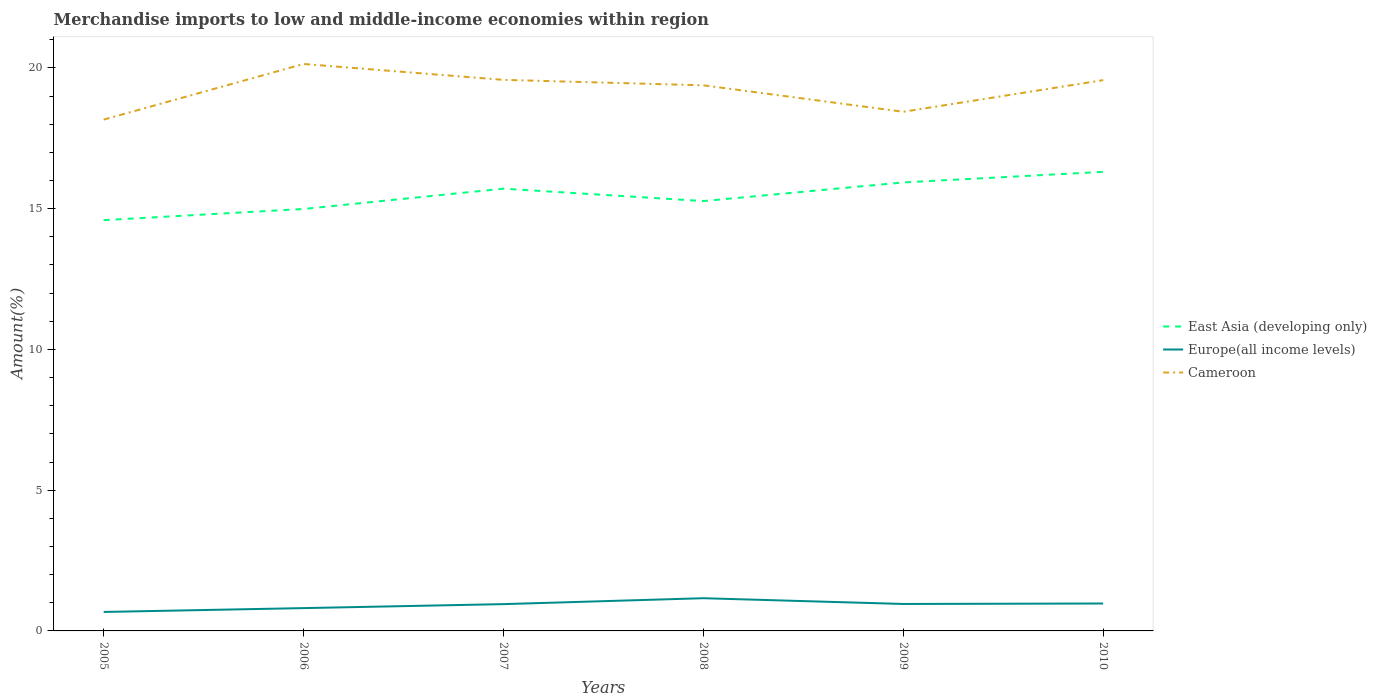Across all years, what is the maximum percentage of amount earned from merchandise imports in East Asia (developing only)?
Make the answer very short. 14.59. In which year was the percentage of amount earned from merchandise imports in East Asia (developing only) maximum?
Offer a very short reply. 2005. What is the total percentage of amount earned from merchandise imports in East Asia (developing only) in the graph?
Your answer should be very brief. -0.28. What is the difference between the highest and the second highest percentage of amount earned from merchandise imports in Europe(all income levels)?
Provide a short and direct response. 0.49. What is the difference between the highest and the lowest percentage of amount earned from merchandise imports in East Asia (developing only)?
Your response must be concise. 3. How many lines are there?
Your answer should be compact. 3. Are the values on the major ticks of Y-axis written in scientific E-notation?
Your response must be concise. No. Does the graph contain grids?
Provide a succinct answer. No. Where does the legend appear in the graph?
Your answer should be compact. Center right. How are the legend labels stacked?
Your answer should be very brief. Vertical. What is the title of the graph?
Your answer should be compact. Merchandise imports to low and middle-income economies within region. What is the label or title of the X-axis?
Ensure brevity in your answer.  Years. What is the label or title of the Y-axis?
Your response must be concise. Amount(%). What is the Amount(%) in East Asia (developing only) in 2005?
Your response must be concise. 14.59. What is the Amount(%) of Europe(all income levels) in 2005?
Give a very brief answer. 0.67. What is the Amount(%) of Cameroon in 2005?
Your answer should be very brief. 18.17. What is the Amount(%) in East Asia (developing only) in 2006?
Your answer should be compact. 14.99. What is the Amount(%) of Europe(all income levels) in 2006?
Provide a short and direct response. 0.81. What is the Amount(%) in Cameroon in 2006?
Ensure brevity in your answer.  20.14. What is the Amount(%) of East Asia (developing only) in 2007?
Provide a short and direct response. 15.71. What is the Amount(%) in Europe(all income levels) in 2007?
Keep it short and to the point. 0.95. What is the Amount(%) in Cameroon in 2007?
Your response must be concise. 19.58. What is the Amount(%) in East Asia (developing only) in 2008?
Give a very brief answer. 15.27. What is the Amount(%) of Europe(all income levels) in 2008?
Keep it short and to the point. 1.16. What is the Amount(%) in Cameroon in 2008?
Your answer should be compact. 19.38. What is the Amount(%) in East Asia (developing only) in 2009?
Give a very brief answer. 15.93. What is the Amount(%) of Europe(all income levels) in 2009?
Your answer should be compact. 0.96. What is the Amount(%) in Cameroon in 2009?
Offer a very short reply. 18.44. What is the Amount(%) of East Asia (developing only) in 2010?
Give a very brief answer. 16.31. What is the Amount(%) in Europe(all income levels) in 2010?
Ensure brevity in your answer.  0.97. What is the Amount(%) of Cameroon in 2010?
Give a very brief answer. 19.57. Across all years, what is the maximum Amount(%) in East Asia (developing only)?
Keep it short and to the point. 16.31. Across all years, what is the maximum Amount(%) of Europe(all income levels)?
Provide a succinct answer. 1.16. Across all years, what is the maximum Amount(%) in Cameroon?
Keep it short and to the point. 20.14. Across all years, what is the minimum Amount(%) of East Asia (developing only)?
Provide a short and direct response. 14.59. Across all years, what is the minimum Amount(%) of Europe(all income levels)?
Offer a terse response. 0.67. Across all years, what is the minimum Amount(%) in Cameroon?
Give a very brief answer. 18.17. What is the total Amount(%) of East Asia (developing only) in the graph?
Offer a very short reply. 92.81. What is the total Amount(%) of Europe(all income levels) in the graph?
Your response must be concise. 5.53. What is the total Amount(%) in Cameroon in the graph?
Provide a succinct answer. 115.28. What is the difference between the Amount(%) in East Asia (developing only) in 2005 and that in 2006?
Make the answer very short. -0.4. What is the difference between the Amount(%) in Europe(all income levels) in 2005 and that in 2006?
Your response must be concise. -0.14. What is the difference between the Amount(%) of Cameroon in 2005 and that in 2006?
Your answer should be compact. -1.98. What is the difference between the Amount(%) in East Asia (developing only) in 2005 and that in 2007?
Make the answer very short. -1.12. What is the difference between the Amount(%) in Europe(all income levels) in 2005 and that in 2007?
Provide a succinct answer. -0.28. What is the difference between the Amount(%) of Cameroon in 2005 and that in 2007?
Provide a succinct answer. -1.41. What is the difference between the Amount(%) of East Asia (developing only) in 2005 and that in 2008?
Ensure brevity in your answer.  -0.68. What is the difference between the Amount(%) in Europe(all income levels) in 2005 and that in 2008?
Make the answer very short. -0.49. What is the difference between the Amount(%) in Cameroon in 2005 and that in 2008?
Offer a terse response. -1.22. What is the difference between the Amount(%) of East Asia (developing only) in 2005 and that in 2009?
Give a very brief answer. -1.34. What is the difference between the Amount(%) in Europe(all income levels) in 2005 and that in 2009?
Give a very brief answer. -0.28. What is the difference between the Amount(%) in Cameroon in 2005 and that in 2009?
Your answer should be compact. -0.28. What is the difference between the Amount(%) in East Asia (developing only) in 2005 and that in 2010?
Give a very brief answer. -1.72. What is the difference between the Amount(%) of Europe(all income levels) in 2005 and that in 2010?
Your answer should be very brief. -0.3. What is the difference between the Amount(%) of Cameroon in 2005 and that in 2010?
Offer a terse response. -1.4. What is the difference between the Amount(%) of East Asia (developing only) in 2006 and that in 2007?
Your answer should be very brief. -0.72. What is the difference between the Amount(%) of Europe(all income levels) in 2006 and that in 2007?
Give a very brief answer. -0.14. What is the difference between the Amount(%) in Cameroon in 2006 and that in 2007?
Ensure brevity in your answer.  0.56. What is the difference between the Amount(%) of East Asia (developing only) in 2006 and that in 2008?
Provide a succinct answer. -0.28. What is the difference between the Amount(%) of Europe(all income levels) in 2006 and that in 2008?
Provide a succinct answer. -0.35. What is the difference between the Amount(%) in Cameroon in 2006 and that in 2008?
Your response must be concise. 0.76. What is the difference between the Amount(%) in East Asia (developing only) in 2006 and that in 2009?
Your answer should be compact. -0.94. What is the difference between the Amount(%) of Europe(all income levels) in 2006 and that in 2009?
Keep it short and to the point. -0.15. What is the difference between the Amount(%) in Cameroon in 2006 and that in 2009?
Your response must be concise. 1.7. What is the difference between the Amount(%) of East Asia (developing only) in 2006 and that in 2010?
Give a very brief answer. -1.32. What is the difference between the Amount(%) in Europe(all income levels) in 2006 and that in 2010?
Your response must be concise. -0.16. What is the difference between the Amount(%) of Cameroon in 2006 and that in 2010?
Make the answer very short. 0.57. What is the difference between the Amount(%) in East Asia (developing only) in 2007 and that in 2008?
Your response must be concise. 0.44. What is the difference between the Amount(%) in Europe(all income levels) in 2007 and that in 2008?
Keep it short and to the point. -0.21. What is the difference between the Amount(%) in Cameroon in 2007 and that in 2008?
Give a very brief answer. 0.19. What is the difference between the Amount(%) of East Asia (developing only) in 2007 and that in 2009?
Keep it short and to the point. -0.22. What is the difference between the Amount(%) in Europe(all income levels) in 2007 and that in 2009?
Ensure brevity in your answer.  -0.01. What is the difference between the Amount(%) of Cameroon in 2007 and that in 2009?
Give a very brief answer. 1.13. What is the difference between the Amount(%) of East Asia (developing only) in 2007 and that in 2010?
Offer a terse response. -0.6. What is the difference between the Amount(%) of Europe(all income levels) in 2007 and that in 2010?
Provide a short and direct response. -0.02. What is the difference between the Amount(%) of East Asia (developing only) in 2008 and that in 2009?
Your answer should be very brief. -0.66. What is the difference between the Amount(%) of Europe(all income levels) in 2008 and that in 2009?
Your response must be concise. 0.2. What is the difference between the Amount(%) of Cameroon in 2008 and that in 2009?
Offer a terse response. 0.94. What is the difference between the Amount(%) of East Asia (developing only) in 2008 and that in 2010?
Keep it short and to the point. -1.04. What is the difference between the Amount(%) in Europe(all income levels) in 2008 and that in 2010?
Offer a terse response. 0.19. What is the difference between the Amount(%) of Cameroon in 2008 and that in 2010?
Your response must be concise. -0.18. What is the difference between the Amount(%) in East Asia (developing only) in 2009 and that in 2010?
Your answer should be compact. -0.38. What is the difference between the Amount(%) of Europe(all income levels) in 2009 and that in 2010?
Keep it short and to the point. -0.02. What is the difference between the Amount(%) of Cameroon in 2009 and that in 2010?
Ensure brevity in your answer.  -1.12. What is the difference between the Amount(%) in East Asia (developing only) in 2005 and the Amount(%) in Europe(all income levels) in 2006?
Your response must be concise. 13.78. What is the difference between the Amount(%) of East Asia (developing only) in 2005 and the Amount(%) of Cameroon in 2006?
Offer a terse response. -5.55. What is the difference between the Amount(%) in Europe(all income levels) in 2005 and the Amount(%) in Cameroon in 2006?
Provide a succinct answer. -19.47. What is the difference between the Amount(%) of East Asia (developing only) in 2005 and the Amount(%) of Europe(all income levels) in 2007?
Provide a succinct answer. 13.64. What is the difference between the Amount(%) in East Asia (developing only) in 2005 and the Amount(%) in Cameroon in 2007?
Offer a very short reply. -4.98. What is the difference between the Amount(%) of Europe(all income levels) in 2005 and the Amount(%) of Cameroon in 2007?
Your answer should be very brief. -18.9. What is the difference between the Amount(%) of East Asia (developing only) in 2005 and the Amount(%) of Europe(all income levels) in 2008?
Offer a terse response. 13.43. What is the difference between the Amount(%) of East Asia (developing only) in 2005 and the Amount(%) of Cameroon in 2008?
Offer a terse response. -4.79. What is the difference between the Amount(%) in Europe(all income levels) in 2005 and the Amount(%) in Cameroon in 2008?
Ensure brevity in your answer.  -18.71. What is the difference between the Amount(%) in East Asia (developing only) in 2005 and the Amount(%) in Europe(all income levels) in 2009?
Keep it short and to the point. 13.64. What is the difference between the Amount(%) in East Asia (developing only) in 2005 and the Amount(%) in Cameroon in 2009?
Keep it short and to the point. -3.85. What is the difference between the Amount(%) in Europe(all income levels) in 2005 and the Amount(%) in Cameroon in 2009?
Your response must be concise. -17.77. What is the difference between the Amount(%) in East Asia (developing only) in 2005 and the Amount(%) in Europe(all income levels) in 2010?
Provide a succinct answer. 13.62. What is the difference between the Amount(%) of East Asia (developing only) in 2005 and the Amount(%) of Cameroon in 2010?
Offer a very short reply. -4.97. What is the difference between the Amount(%) of Europe(all income levels) in 2005 and the Amount(%) of Cameroon in 2010?
Provide a succinct answer. -18.89. What is the difference between the Amount(%) in East Asia (developing only) in 2006 and the Amount(%) in Europe(all income levels) in 2007?
Ensure brevity in your answer.  14.04. What is the difference between the Amount(%) in East Asia (developing only) in 2006 and the Amount(%) in Cameroon in 2007?
Provide a succinct answer. -4.59. What is the difference between the Amount(%) in Europe(all income levels) in 2006 and the Amount(%) in Cameroon in 2007?
Offer a very short reply. -18.77. What is the difference between the Amount(%) of East Asia (developing only) in 2006 and the Amount(%) of Europe(all income levels) in 2008?
Keep it short and to the point. 13.83. What is the difference between the Amount(%) in East Asia (developing only) in 2006 and the Amount(%) in Cameroon in 2008?
Your answer should be compact. -4.39. What is the difference between the Amount(%) of Europe(all income levels) in 2006 and the Amount(%) of Cameroon in 2008?
Provide a succinct answer. -18.57. What is the difference between the Amount(%) in East Asia (developing only) in 2006 and the Amount(%) in Europe(all income levels) in 2009?
Your answer should be very brief. 14.03. What is the difference between the Amount(%) in East Asia (developing only) in 2006 and the Amount(%) in Cameroon in 2009?
Offer a terse response. -3.45. What is the difference between the Amount(%) in Europe(all income levels) in 2006 and the Amount(%) in Cameroon in 2009?
Provide a succinct answer. -17.63. What is the difference between the Amount(%) in East Asia (developing only) in 2006 and the Amount(%) in Europe(all income levels) in 2010?
Provide a succinct answer. 14.02. What is the difference between the Amount(%) in East Asia (developing only) in 2006 and the Amount(%) in Cameroon in 2010?
Keep it short and to the point. -4.58. What is the difference between the Amount(%) in Europe(all income levels) in 2006 and the Amount(%) in Cameroon in 2010?
Keep it short and to the point. -18.76. What is the difference between the Amount(%) in East Asia (developing only) in 2007 and the Amount(%) in Europe(all income levels) in 2008?
Provide a succinct answer. 14.55. What is the difference between the Amount(%) in East Asia (developing only) in 2007 and the Amount(%) in Cameroon in 2008?
Give a very brief answer. -3.67. What is the difference between the Amount(%) of Europe(all income levels) in 2007 and the Amount(%) of Cameroon in 2008?
Offer a terse response. -18.43. What is the difference between the Amount(%) in East Asia (developing only) in 2007 and the Amount(%) in Europe(all income levels) in 2009?
Your response must be concise. 14.75. What is the difference between the Amount(%) of East Asia (developing only) in 2007 and the Amount(%) of Cameroon in 2009?
Keep it short and to the point. -2.73. What is the difference between the Amount(%) of Europe(all income levels) in 2007 and the Amount(%) of Cameroon in 2009?
Keep it short and to the point. -17.49. What is the difference between the Amount(%) of East Asia (developing only) in 2007 and the Amount(%) of Europe(all income levels) in 2010?
Offer a very short reply. 14.74. What is the difference between the Amount(%) of East Asia (developing only) in 2007 and the Amount(%) of Cameroon in 2010?
Your answer should be very brief. -3.86. What is the difference between the Amount(%) in Europe(all income levels) in 2007 and the Amount(%) in Cameroon in 2010?
Make the answer very short. -18.61. What is the difference between the Amount(%) in East Asia (developing only) in 2008 and the Amount(%) in Europe(all income levels) in 2009?
Give a very brief answer. 14.31. What is the difference between the Amount(%) in East Asia (developing only) in 2008 and the Amount(%) in Cameroon in 2009?
Give a very brief answer. -3.17. What is the difference between the Amount(%) in Europe(all income levels) in 2008 and the Amount(%) in Cameroon in 2009?
Make the answer very short. -17.28. What is the difference between the Amount(%) in East Asia (developing only) in 2008 and the Amount(%) in Europe(all income levels) in 2010?
Ensure brevity in your answer.  14.3. What is the difference between the Amount(%) in East Asia (developing only) in 2008 and the Amount(%) in Cameroon in 2010?
Ensure brevity in your answer.  -4.3. What is the difference between the Amount(%) of Europe(all income levels) in 2008 and the Amount(%) of Cameroon in 2010?
Your response must be concise. -18.4. What is the difference between the Amount(%) in East Asia (developing only) in 2009 and the Amount(%) in Europe(all income levels) in 2010?
Give a very brief answer. 14.96. What is the difference between the Amount(%) in East Asia (developing only) in 2009 and the Amount(%) in Cameroon in 2010?
Provide a short and direct response. -3.63. What is the difference between the Amount(%) in Europe(all income levels) in 2009 and the Amount(%) in Cameroon in 2010?
Make the answer very short. -18.61. What is the average Amount(%) in East Asia (developing only) per year?
Your response must be concise. 15.47. What is the average Amount(%) of Europe(all income levels) per year?
Provide a short and direct response. 0.92. What is the average Amount(%) of Cameroon per year?
Your answer should be compact. 19.21. In the year 2005, what is the difference between the Amount(%) in East Asia (developing only) and Amount(%) in Europe(all income levels)?
Give a very brief answer. 13.92. In the year 2005, what is the difference between the Amount(%) of East Asia (developing only) and Amount(%) of Cameroon?
Offer a terse response. -3.57. In the year 2005, what is the difference between the Amount(%) of Europe(all income levels) and Amount(%) of Cameroon?
Your answer should be compact. -17.49. In the year 2006, what is the difference between the Amount(%) of East Asia (developing only) and Amount(%) of Europe(all income levels)?
Provide a succinct answer. 14.18. In the year 2006, what is the difference between the Amount(%) of East Asia (developing only) and Amount(%) of Cameroon?
Your answer should be very brief. -5.15. In the year 2006, what is the difference between the Amount(%) in Europe(all income levels) and Amount(%) in Cameroon?
Keep it short and to the point. -19.33. In the year 2007, what is the difference between the Amount(%) of East Asia (developing only) and Amount(%) of Europe(all income levels)?
Offer a terse response. 14.76. In the year 2007, what is the difference between the Amount(%) of East Asia (developing only) and Amount(%) of Cameroon?
Offer a very short reply. -3.87. In the year 2007, what is the difference between the Amount(%) in Europe(all income levels) and Amount(%) in Cameroon?
Provide a succinct answer. -18.62. In the year 2008, what is the difference between the Amount(%) in East Asia (developing only) and Amount(%) in Europe(all income levels)?
Offer a terse response. 14.11. In the year 2008, what is the difference between the Amount(%) of East Asia (developing only) and Amount(%) of Cameroon?
Your answer should be compact. -4.11. In the year 2008, what is the difference between the Amount(%) of Europe(all income levels) and Amount(%) of Cameroon?
Offer a very short reply. -18.22. In the year 2009, what is the difference between the Amount(%) of East Asia (developing only) and Amount(%) of Europe(all income levels)?
Offer a terse response. 14.98. In the year 2009, what is the difference between the Amount(%) of East Asia (developing only) and Amount(%) of Cameroon?
Offer a very short reply. -2.51. In the year 2009, what is the difference between the Amount(%) in Europe(all income levels) and Amount(%) in Cameroon?
Provide a short and direct response. -17.49. In the year 2010, what is the difference between the Amount(%) in East Asia (developing only) and Amount(%) in Europe(all income levels)?
Offer a terse response. 15.33. In the year 2010, what is the difference between the Amount(%) in East Asia (developing only) and Amount(%) in Cameroon?
Your answer should be compact. -3.26. In the year 2010, what is the difference between the Amount(%) of Europe(all income levels) and Amount(%) of Cameroon?
Your response must be concise. -18.59. What is the ratio of the Amount(%) in East Asia (developing only) in 2005 to that in 2006?
Give a very brief answer. 0.97. What is the ratio of the Amount(%) of Europe(all income levels) in 2005 to that in 2006?
Your answer should be very brief. 0.83. What is the ratio of the Amount(%) in Cameroon in 2005 to that in 2006?
Offer a terse response. 0.9. What is the ratio of the Amount(%) of East Asia (developing only) in 2005 to that in 2007?
Provide a short and direct response. 0.93. What is the ratio of the Amount(%) of Europe(all income levels) in 2005 to that in 2007?
Your answer should be compact. 0.71. What is the ratio of the Amount(%) in Cameroon in 2005 to that in 2007?
Provide a short and direct response. 0.93. What is the ratio of the Amount(%) in East Asia (developing only) in 2005 to that in 2008?
Keep it short and to the point. 0.96. What is the ratio of the Amount(%) in Europe(all income levels) in 2005 to that in 2008?
Make the answer very short. 0.58. What is the ratio of the Amount(%) in Cameroon in 2005 to that in 2008?
Give a very brief answer. 0.94. What is the ratio of the Amount(%) of East Asia (developing only) in 2005 to that in 2009?
Give a very brief answer. 0.92. What is the ratio of the Amount(%) in Europe(all income levels) in 2005 to that in 2009?
Your response must be concise. 0.7. What is the ratio of the Amount(%) of Cameroon in 2005 to that in 2009?
Keep it short and to the point. 0.98. What is the ratio of the Amount(%) in East Asia (developing only) in 2005 to that in 2010?
Keep it short and to the point. 0.89. What is the ratio of the Amount(%) of Europe(all income levels) in 2005 to that in 2010?
Make the answer very short. 0.69. What is the ratio of the Amount(%) of Cameroon in 2005 to that in 2010?
Make the answer very short. 0.93. What is the ratio of the Amount(%) of East Asia (developing only) in 2006 to that in 2007?
Provide a short and direct response. 0.95. What is the ratio of the Amount(%) of Europe(all income levels) in 2006 to that in 2007?
Keep it short and to the point. 0.85. What is the ratio of the Amount(%) in Cameroon in 2006 to that in 2007?
Make the answer very short. 1.03. What is the ratio of the Amount(%) in East Asia (developing only) in 2006 to that in 2008?
Your response must be concise. 0.98. What is the ratio of the Amount(%) of Europe(all income levels) in 2006 to that in 2008?
Your response must be concise. 0.7. What is the ratio of the Amount(%) in Cameroon in 2006 to that in 2008?
Give a very brief answer. 1.04. What is the ratio of the Amount(%) in East Asia (developing only) in 2006 to that in 2009?
Give a very brief answer. 0.94. What is the ratio of the Amount(%) of Europe(all income levels) in 2006 to that in 2009?
Offer a very short reply. 0.85. What is the ratio of the Amount(%) of Cameroon in 2006 to that in 2009?
Give a very brief answer. 1.09. What is the ratio of the Amount(%) in East Asia (developing only) in 2006 to that in 2010?
Your response must be concise. 0.92. What is the ratio of the Amount(%) in Europe(all income levels) in 2006 to that in 2010?
Keep it short and to the point. 0.83. What is the ratio of the Amount(%) of Cameroon in 2006 to that in 2010?
Offer a terse response. 1.03. What is the ratio of the Amount(%) in East Asia (developing only) in 2007 to that in 2008?
Provide a short and direct response. 1.03. What is the ratio of the Amount(%) in Europe(all income levels) in 2007 to that in 2008?
Your answer should be compact. 0.82. What is the ratio of the Amount(%) in Cameroon in 2007 to that in 2008?
Provide a short and direct response. 1.01. What is the ratio of the Amount(%) of East Asia (developing only) in 2007 to that in 2009?
Keep it short and to the point. 0.99. What is the ratio of the Amount(%) in Europe(all income levels) in 2007 to that in 2009?
Give a very brief answer. 0.99. What is the ratio of the Amount(%) in Cameroon in 2007 to that in 2009?
Provide a short and direct response. 1.06. What is the ratio of the Amount(%) in East Asia (developing only) in 2007 to that in 2010?
Offer a very short reply. 0.96. What is the ratio of the Amount(%) of Europe(all income levels) in 2007 to that in 2010?
Your answer should be compact. 0.98. What is the ratio of the Amount(%) of Cameroon in 2007 to that in 2010?
Ensure brevity in your answer.  1. What is the ratio of the Amount(%) of East Asia (developing only) in 2008 to that in 2009?
Ensure brevity in your answer.  0.96. What is the ratio of the Amount(%) of Europe(all income levels) in 2008 to that in 2009?
Offer a very short reply. 1.21. What is the ratio of the Amount(%) in Cameroon in 2008 to that in 2009?
Your answer should be very brief. 1.05. What is the ratio of the Amount(%) in East Asia (developing only) in 2008 to that in 2010?
Provide a succinct answer. 0.94. What is the ratio of the Amount(%) of Europe(all income levels) in 2008 to that in 2010?
Provide a short and direct response. 1.19. What is the ratio of the Amount(%) in Cameroon in 2008 to that in 2010?
Ensure brevity in your answer.  0.99. What is the ratio of the Amount(%) in East Asia (developing only) in 2009 to that in 2010?
Provide a succinct answer. 0.98. What is the ratio of the Amount(%) in Europe(all income levels) in 2009 to that in 2010?
Provide a short and direct response. 0.98. What is the ratio of the Amount(%) in Cameroon in 2009 to that in 2010?
Provide a short and direct response. 0.94. What is the difference between the highest and the second highest Amount(%) in East Asia (developing only)?
Keep it short and to the point. 0.38. What is the difference between the highest and the second highest Amount(%) of Europe(all income levels)?
Keep it short and to the point. 0.19. What is the difference between the highest and the second highest Amount(%) in Cameroon?
Your response must be concise. 0.56. What is the difference between the highest and the lowest Amount(%) of East Asia (developing only)?
Give a very brief answer. 1.72. What is the difference between the highest and the lowest Amount(%) of Europe(all income levels)?
Your response must be concise. 0.49. What is the difference between the highest and the lowest Amount(%) of Cameroon?
Provide a short and direct response. 1.98. 